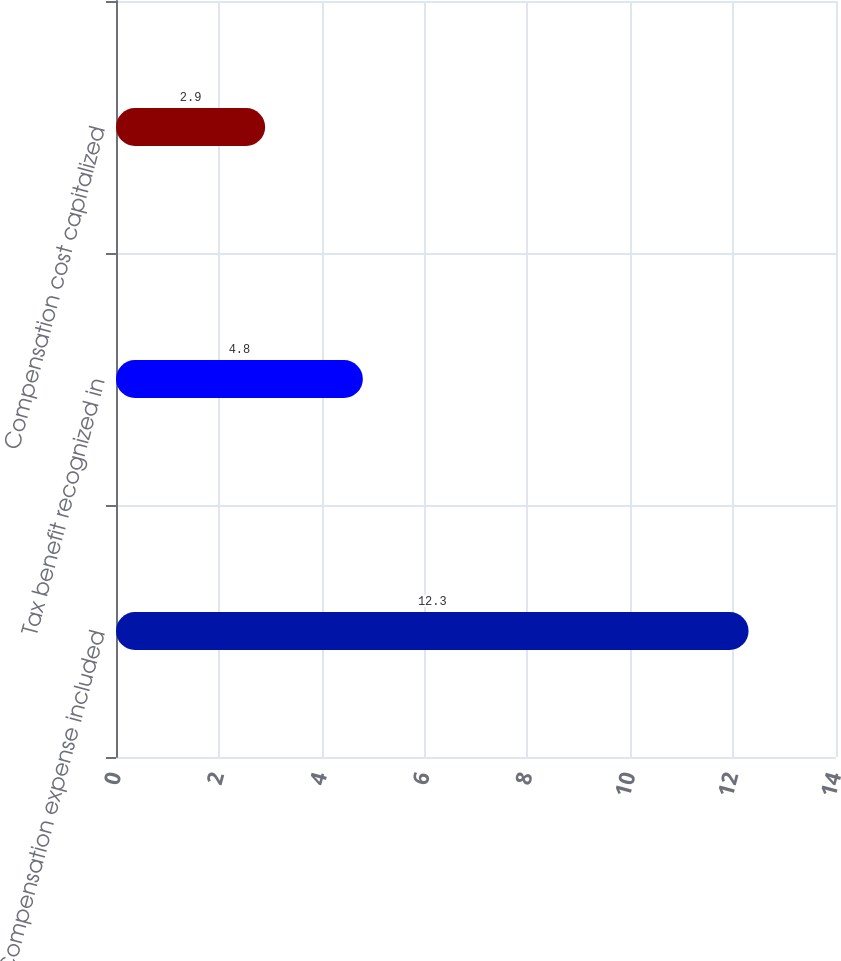Convert chart to OTSL. <chart><loc_0><loc_0><loc_500><loc_500><bar_chart><fcel>Compensation expense included<fcel>Tax benefit recognized in<fcel>Compensation cost capitalized<nl><fcel>12.3<fcel>4.8<fcel>2.9<nl></chart> 